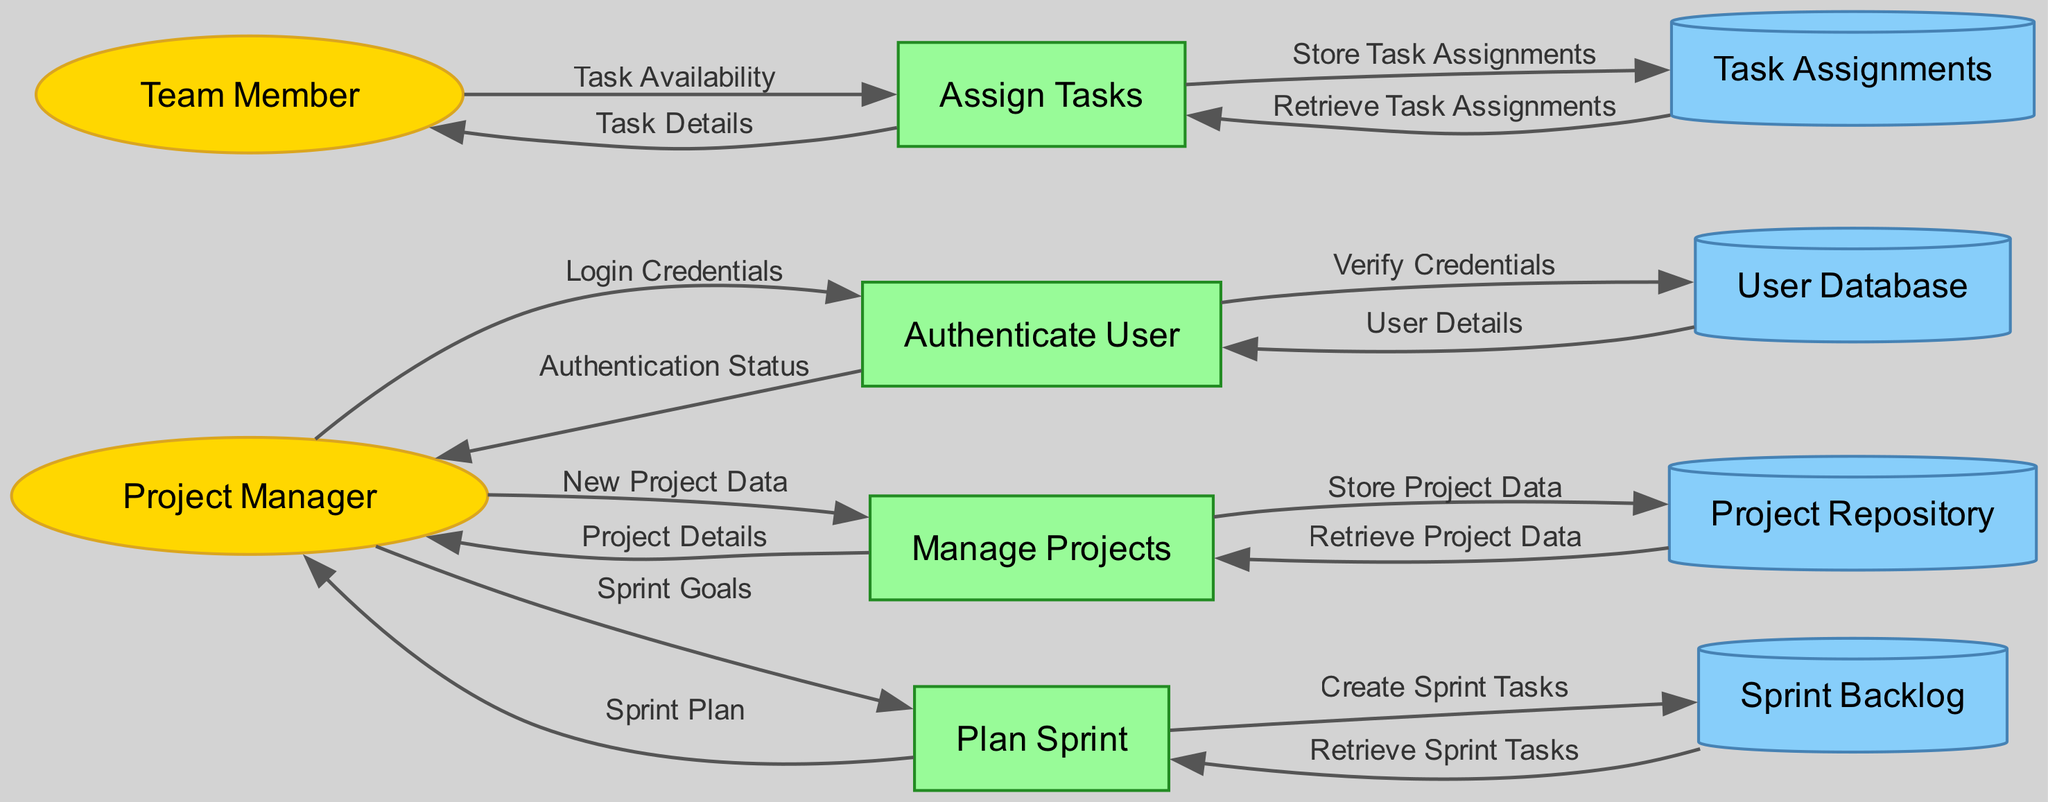What external entity interacts with the "Authenticate User" process? The external entity corresponding to the "Authenticate User" process is the "Project Manager," indicating that this is the user initiating the authentication process.
Answer: Project Manager How many data stores are represented in the diagram? By examining the diagram, we can count three distinct data stores: "User Database," "Project Repository," and "Sprint Backlog." Each represents a different set of stored information within the workflow.
Answer: Three Which process is responsible for managing project data? The process named "Manage Projects" directly handles the management of project data as indicated by its title and the associated data flows.
Answer: Manage Projects What data flows from the "Team Member" to the "Assign Tasks" process? The data flow from the "Team Member" to the "Assign Tasks" process is labeled "Task Availability," indicating that team members report their availability for tasks.
Answer: Task Availability What is the final output from the "Plan Sprint" process? The final output from the "Plan Sprint" process is the "Sprint Plan," which is provided to the "Project Manager" as the end result of sprint planning.
Answer: Sprint Plan Which data store is associated with creating sprint tasks? The "Sprint Backlog" data store is connected to the creation of sprint tasks as indicated by the flow labeled "Create Sprint Tasks" from the "Plan Sprint" process to this data store.
Answer: Sprint Backlog How many data flows connect the "Manage Projects" process to the "Project Manager"? There are two data flows connecting the "Manage Projects" process to the "Project Manager": one for "Project Details" and another for "New Project Data." This indicates both input and output interactions.
Answer: Two Which process interacts with the "User Database"? The "Authenticate User" process interacts with the "User Database" for verifying user credentials and retrieving user details, highlighting the relationship between authentication and user information.
Answer: Authenticate User 